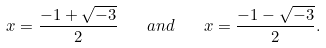<formula> <loc_0><loc_0><loc_500><loc_500>x = { \frac { - 1 + { \sqrt { - 3 } } } { 2 } } \quad a n d \quad x = { \frac { - 1 - { \sqrt { - 3 } } } { 2 } } .</formula> 